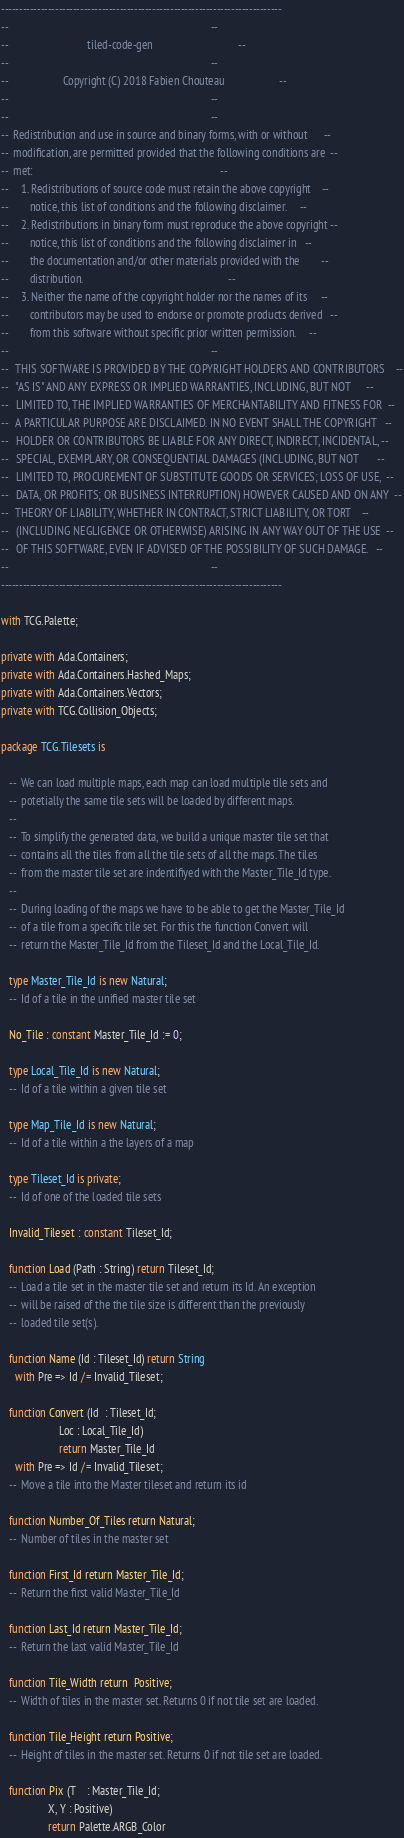Convert code to text. <code><loc_0><loc_0><loc_500><loc_500><_Ada_>------------------------------------------------------------------------------
--                                                                          --
--                             tiled-code-gen                               --
--                                                                          --
--                    Copyright (C) 2018 Fabien Chouteau                    --
--                                                                          --
--                                                                          --
--  Redistribution and use in source and binary forms, with or without      --
--  modification, are permitted provided that the following conditions are  --
--  met:                                                                    --
--     1. Redistributions of source code must retain the above copyright    --
--        notice, this list of conditions and the following disclaimer.     --
--     2. Redistributions in binary form must reproduce the above copyright --
--        notice, this list of conditions and the following disclaimer in   --
--        the documentation and/or other materials provided with the        --
--        distribution.                                                     --
--     3. Neither the name of the copyright holder nor the names of its     --
--        contributors may be used to endorse or promote products derived   --
--        from this software without specific prior written permission.     --
--                                                                          --
--   THIS SOFTWARE IS PROVIDED BY THE COPYRIGHT HOLDERS AND CONTRIBUTORS    --
--   "AS IS" AND ANY EXPRESS OR IMPLIED WARRANTIES, INCLUDING, BUT NOT      --
--   LIMITED TO, THE IMPLIED WARRANTIES OF MERCHANTABILITY AND FITNESS FOR  --
--   A PARTICULAR PURPOSE ARE DISCLAIMED. IN NO EVENT SHALL THE COPYRIGHT   --
--   HOLDER OR CONTRIBUTORS BE LIABLE FOR ANY DIRECT, INDIRECT, INCIDENTAL, --
--   SPECIAL, EXEMPLARY, OR CONSEQUENTIAL DAMAGES (INCLUDING, BUT NOT       --
--   LIMITED TO, PROCUREMENT OF SUBSTITUTE GOODS OR SERVICES; LOSS OF USE,  --
--   DATA, OR PROFITS; OR BUSINESS INTERRUPTION) HOWEVER CAUSED AND ON ANY  --
--   THEORY OF LIABILITY, WHETHER IN CONTRACT, STRICT LIABILITY, OR TORT    --
--   (INCLUDING NEGLIGENCE OR OTHERWISE) ARISING IN ANY WAY OUT OF THE USE  --
--   OF THIS SOFTWARE, EVEN IF ADVISED OF THE POSSIBILITY OF SUCH DAMAGE.   --
--                                                                          --
------------------------------------------------------------------------------

with TCG.Palette;

private with Ada.Containers;
private with Ada.Containers.Hashed_Maps;
private with Ada.Containers.Vectors;
private with TCG.Collision_Objects;

package TCG.Tilesets is

   --  We can load multiple maps, each map can load multiple tile sets and
   --  potetially the same tile sets will be loaded by different maps.
   --
   --  To simplify the generated data, we build a unique master tile set that
   --  contains all the tiles from all the tile sets of all the maps. The tiles
   --  from the master tile set are indentifiyed with the Master_Tile_Id type.
   --
   --  During loading of the maps we have to be able to get the Master_Tile_Id
   --  of a tile from a specific tile set. For this the function Convert will
   --  return the Master_Tile_Id from the Tileset_Id and the Local_Tile_Id.

   type Master_Tile_Id is new Natural;
   --  Id of a tile in the unified master tile set

   No_Tile : constant Master_Tile_Id := 0;

   type Local_Tile_Id is new Natural;
   --  Id of a tile within a given tile set

   type Map_Tile_Id is new Natural;
   --  Id of a tile within a the layers of a map

   type Tileset_Id is private;
   --  Id of one of the loaded tile sets

   Invalid_Tileset : constant Tileset_Id;

   function Load (Path : String) return Tileset_Id;
   --  Load a tile set in the master tile set and return its Id. An exception
   --  will be raised of the the tile size is different than the previously
   --  loaded tile set(s).

   function Name (Id : Tileset_Id) return String
     with Pre => Id /= Invalid_Tileset;

   function Convert (Id  : Tileset_Id;
                     Loc : Local_Tile_Id)
                     return Master_Tile_Id
     with Pre => Id /= Invalid_Tileset;
   --  Move a tile into the Master tileset and return its id

   function Number_Of_Tiles return Natural;
   --  Number of tiles in the master set

   function First_Id return Master_Tile_Id;
   --  Return the first valid Master_Tile_Id

   function Last_Id return Master_Tile_Id;
   --  Return the last valid Master_Tile_Id

   function Tile_Width return  Positive;
   --  Width of tiles in the master set. Returns 0 if not tile set are loaded.

   function Tile_Height return Positive;
   --  Height of tiles in the master set. Returns 0 if not tile set are loaded.

   function Pix (T    : Master_Tile_Id;
                 X, Y : Positive)
                 return Palette.ARGB_Color</code> 